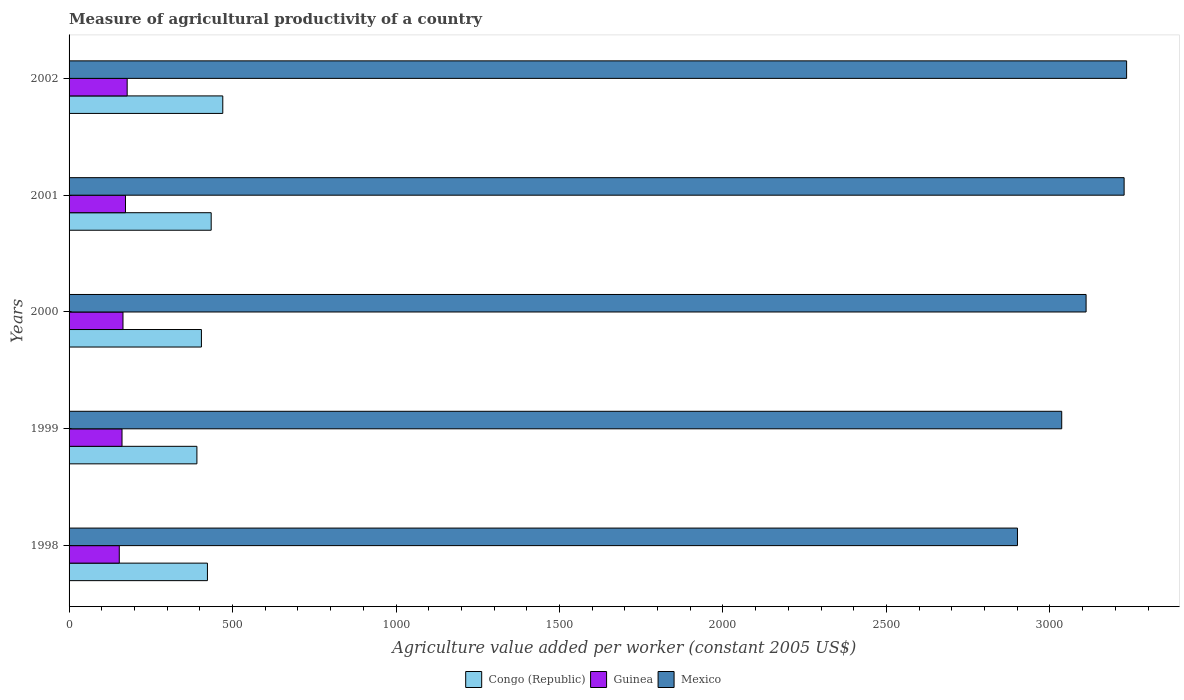How many groups of bars are there?
Make the answer very short. 5. Are the number of bars per tick equal to the number of legend labels?
Keep it short and to the point. Yes. How many bars are there on the 5th tick from the bottom?
Keep it short and to the point. 3. What is the label of the 1st group of bars from the top?
Your answer should be compact. 2002. What is the measure of agricultural productivity in Mexico in 2002?
Your answer should be very brief. 3234.55. Across all years, what is the maximum measure of agricultural productivity in Guinea?
Your answer should be compact. 177.71. Across all years, what is the minimum measure of agricultural productivity in Guinea?
Provide a short and direct response. 153.55. In which year was the measure of agricultural productivity in Congo (Republic) maximum?
Your answer should be compact. 2002. What is the total measure of agricultural productivity in Mexico in the graph?
Offer a very short reply. 1.55e+04. What is the difference between the measure of agricultural productivity in Congo (Republic) in 1998 and that in 2001?
Your answer should be very brief. -11.48. What is the difference between the measure of agricultural productivity in Guinea in 1998 and the measure of agricultural productivity in Mexico in 2002?
Your response must be concise. -3081. What is the average measure of agricultural productivity in Mexico per year?
Your answer should be compact. 3101.79. In the year 2001, what is the difference between the measure of agricultural productivity in Guinea and measure of agricultural productivity in Mexico?
Your answer should be compact. -3054.34. In how many years, is the measure of agricultural productivity in Mexico greater than 1200 US$?
Make the answer very short. 5. What is the ratio of the measure of agricultural productivity in Mexico in 2000 to that in 2001?
Ensure brevity in your answer.  0.96. Is the measure of agricultural productivity in Congo (Republic) in 1998 less than that in 2000?
Your response must be concise. No. What is the difference between the highest and the second highest measure of agricultural productivity in Guinea?
Make the answer very short. 5.1. What is the difference between the highest and the lowest measure of agricultural productivity in Mexico?
Ensure brevity in your answer.  333.81. Is the sum of the measure of agricultural productivity in Guinea in 1999 and 2001 greater than the maximum measure of agricultural productivity in Mexico across all years?
Keep it short and to the point. No. What does the 3rd bar from the top in 2001 represents?
Ensure brevity in your answer.  Congo (Republic). What does the 1st bar from the bottom in 2001 represents?
Keep it short and to the point. Congo (Republic). Is it the case that in every year, the sum of the measure of agricultural productivity in Congo (Republic) and measure of agricultural productivity in Guinea is greater than the measure of agricultural productivity in Mexico?
Give a very brief answer. No. How many bars are there?
Ensure brevity in your answer.  15. How many years are there in the graph?
Offer a terse response. 5. Does the graph contain grids?
Give a very brief answer. No. Where does the legend appear in the graph?
Ensure brevity in your answer.  Bottom center. How many legend labels are there?
Your answer should be very brief. 3. How are the legend labels stacked?
Give a very brief answer. Horizontal. What is the title of the graph?
Ensure brevity in your answer.  Measure of agricultural productivity of a country. What is the label or title of the X-axis?
Your response must be concise. Agriculture value added per worker (constant 2005 US$). What is the label or title of the Y-axis?
Your answer should be compact. Years. What is the Agriculture value added per worker (constant 2005 US$) of Congo (Republic) in 1998?
Ensure brevity in your answer.  423.21. What is the Agriculture value added per worker (constant 2005 US$) in Guinea in 1998?
Give a very brief answer. 153.55. What is the Agriculture value added per worker (constant 2005 US$) in Mexico in 1998?
Ensure brevity in your answer.  2900.74. What is the Agriculture value added per worker (constant 2005 US$) of Congo (Republic) in 1999?
Provide a short and direct response. 391.01. What is the Agriculture value added per worker (constant 2005 US$) in Guinea in 1999?
Provide a short and direct response. 161.95. What is the Agriculture value added per worker (constant 2005 US$) of Mexico in 1999?
Your answer should be very brief. 3036.08. What is the Agriculture value added per worker (constant 2005 US$) of Congo (Republic) in 2000?
Give a very brief answer. 404.82. What is the Agriculture value added per worker (constant 2005 US$) of Guinea in 2000?
Offer a very short reply. 164.91. What is the Agriculture value added per worker (constant 2005 US$) in Mexico in 2000?
Keep it short and to the point. 3110.61. What is the Agriculture value added per worker (constant 2005 US$) in Congo (Republic) in 2001?
Keep it short and to the point. 434.69. What is the Agriculture value added per worker (constant 2005 US$) of Guinea in 2001?
Provide a short and direct response. 172.61. What is the Agriculture value added per worker (constant 2005 US$) of Mexico in 2001?
Keep it short and to the point. 3226.94. What is the Agriculture value added per worker (constant 2005 US$) in Congo (Republic) in 2002?
Keep it short and to the point. 470.11. What is the Agriculture value added per worker (constant 2005 US$) of Guinea in 2002?
Give a very brief answer. 177.71. What is the Agriculture value added per worker (constant 2005 US$) in Mexico in 2002?
Offer a very short reply. 3234.55. Across all years, what is the maximum Agriculture value added per worker (constant 2005 US$) in Congo (Republic)?
Give a very brief answer. 470.11. Across all years, what is the maximum Agriculture value added per worker (constant 2005 US$) in Guinea?
Your answer should be compact. 177.71. Across all years, what is the maximum Agriculture value added per worker (constant 2005 US$) of Mexico?
Provide a short and direct response. 3234.55. Across all years, what is the minimum Agriculture value added per worker (constant 2005 US$) in Congo (Republic)?
Keep it short and to the point. 391.01. Across all years, what is the minimum Agriculture value added per worker (constant 2005 US$) of Guinea?
Your response must be concise. 153.55. Across all years, what is the minimum Agriculture value added per worker (constant 2005 US$) of Mexico?
Ensure brevity in your answer.  2900.74. What is the total Agriculture value added per worker (constant 2005 US$) of Congo (Republic) in the graph?
Keep it short and to the point. 2123.84. What is the total Agriculture value added per worker (constant 2005 US$) of Guinea in the graph?
Make the answer very short. 830.73. What is the total Agriculture value added per worker (constant 2005 US$) of Mexico in the graph?
Offer a very short reply. 1.55e+04. What is the difference between the Agriculture value added per worker (constant 2005 US$) in Congo (Republic) in 1998 and that in 1999?
Give a very brief answer. 32.2. What is the difference between the Agriculture value added per worker (constant 2005 US$) in Guinea in 1998 and that in 1999?
Make the answer very short. -8.4. What is the difference between the Agriculture value added per worker (constant 2005 US$) of Mexico in 1998 and that in 1999?
Offer a very short reply. -135.34. What is the difference between the Agriculture value added per worker (constant 2005 US$) in Congo (Republic) in 1998 and that in 2000?
Keep it short and to the point. 18.39. What is the difference between the Agriculture value added per worker (constant 2005 US$) of Guinea in 1998 and that in 2000?
Ensure brevity in your answer.  -11.36. What is the difference between the Agriculture value added per worker (constant 2005 US$) of Mexico in 1998 and that in 2000?
Keep it short and to the point. -209.87. What is the difference between the Agriculture value added per worker (constant 2005 US$) of Congo (Republic) in 1998 and that in 2001?
Give a very brief answer. -11.48. What is the difference between the Agriculture value added per worker (constant 2005 US$) of Guinea in 1998 and that in 2001?
Your response must be concise. -19.06. What is the difference between the Agriculture value added per worker (constant 2005 US$) of Mexico in 1998 and that in 2001?
Offer a terse response. -326.2. What is the difference between the Agriculture value added per worker (constant 2005 US$) in Congo (Republic) in 1998 and that in 2002?
Offer a terse response. -46.9. What is the difference between the Agriculture value added per worker (constant 2005 US$) of Guinea in 1998 and that in 2002?
Keep it short and to the point. -24.16. What is the difference between the Agriculture value added per worker (constant 2005 US$) in Mexico in 1998 and that in 2002?
Offer a terse response. -333.81. What is the difference between the Agriculture value added per worker (constant 2005 US$) of Congo (Republic) in 1999 and that in 2000?
Give a very brief answer. -13.8. What is the difference between the Agriculture value added per worker (constant 2005 US$) of Guinea in 1999 and that in 2000?
Provide a succinct answer. -2.96. What is the difference between the Agriculture value added per worker (constant 2005 US$) of Mexico in 1999 and that in 2000?
Make the answer very short. -74.53. What is the difference between the Agriculture value added per worker (constant 2005 US$) in Congo (Republic) in 1999 and that in 2001?
Keep it short and to the point. -43.68. What is the difference between the Agriculture value added per worker (constant 2005 US$) of Guinea in 1999 and that in 2001?
Provide a short and direct response. -10.66. What is the difference between the Agriculture value added per worker (constant 2005 US$) in Mexico in 1999 and that in 2001?
Keep it short and to the point. -190.87. What is the difference between the Agriculture value added per worker (constant 2005 US$) of Congo (Republic) in 1999 and that in 2002?
Provide a succinct answer. -79.1. What is the difference between the Agriculture value added per worker (constant 2005 US$) in Guinea in 1999 and that in 2002?
Your answer should be very brief. -15.76. What is the difference between the Agriculture value added per worker (constant 2005 US$) of Mexico in 1999 and that in 2002?
Make the answer very short. -198.47. What is the difference between the Agriculture value added per worker (constant 2005 US$) of Congo (Republic) in 2000 and that in 2001?
Provide a succinct answer. -29.87. What is the difference between the Agriculture value added per worker (constant 2005 US$) of Guinea in 2000 and that in 2001?
Make the answer very short. -7.69. What is the difference between the Agriculture value added per worker (constant 2005 US$) of Mexico in 2000 and that in 2001?
Keep it short and to the point. -116.33. What is the difference between the Agriculture value added per worker (constant 2005 US$) of Congo (Republic) in 2000 and that in 2002?
Make the answer very short. -65.29. What is the difference between the Agriculture value added per worker (constant 2005 US$) of Guinea in 2000 and that in 2002?
Make the answer very short. -12.79. What is the difference between the Agriculture value added per worker (constant 2005 US$) in Mexico in 2000 and that in 2002?
Your answer should be compact. -123.94. What is the difference between the Agriculture value added per worker (constant 2005 US$) of Congo (Republic) in 2001 and that in 2002?
Offer a terse response. -35.42. What is the difference between the Agriculture value added per worker (constant 2005 US$) in Guinea in 2001 and that in 2002?
Ensure brevity in your answer.  -5.1. What is the difference between the Agriculture value added per worker (constant 2005 US$) of Mexico in 2001 and that in 2002?
Offer a terse response. -7.61. What is the difference between the Agriculture value added per worker (constant 2005 US$) in Congo (Republic) in 1998 and the Agriculture value added per worker (constant 2005 US$) in Guinea in 1999?
Provide a succinct answer. 261.26. What is the difference between the Agriculture value added per worker (constant 2005 US$) of Congo (Republic) in 1998 and the Agriculture value added per worker (constant 2005 US$) of Mexico in 1999?
Give a very brief answer. -2612.87. What is the difference between the Agriculture value added per worker (constant 2005 US$) in Guinea in 1998 and the Agriculture value added per worker (constant 2005 US$) in Mexico in 1999?
Your answer should be compact. -2882.53. What is the difference between the Agriculture value added per worker (constant 2005 US$) of Congo (Republic) in 1998 and the Agriculture value added per worker (constant 2005 US$) of Guinea in 2000?
Give a very brief answer. 258.3. What is the difference between the Agriculture value added per worker (constant 2005 US$) in Congo (Republic) in 1998 and the Agriculture value added per worker (constant 2005 US$) in Mexico in 2000?
Provide a succinct answer. -2687.4. What is the difference between the Agriculture value added per worker (constant 2005 US$) of Guinea in 1998 and the Agriculture value added per worker (constant 2005 US$) of Mexico in 2000?
Provide a succinct answer. -2957.06. What is the difference between the Agriculture value added per worker (constant 2005 US$) of Congo (Republic) in 1998 and the Agriculture value added per worker (constant 2005 US$) of Guinea in 2001?
Provide a short and direct response. 250.6. What is the difference between the Agriculture value added per worker (constant 2005 US$) in Congo (Republic) in 1998 and the Agriculture value added per worker (constant 2005 US$) in Mexico in 2001?
Offer a very short reply. -2803.73. What is the difference between the Agriculture value added per worker (constant 2005 US$) in Guinea in 1998 and the Agriculture value added per worker (constant 2005 US$) in Mexico in 2001?
Give a very brief answer. -3073.39. What is the difference between the Agriculture value added per worker (constant 2005 US$) of Congo (Republic) in 1998 and the Agriculture value added per worker (constant 2005 US$) of Guinea in 2002?
Your response must be concise. 245.5. What is the difference between the Agriculture value added per worker (constant 2005 US$) in Congo (Republic) in 1998 and the Agriculture value added per worker (constant 2005 US$) in Mexico in 2002?
Your answer should be very brief. -2811.34. What is the difference between the Agriculture value added per worker (constant 2005 US$) of Guinea in 1998 and the Agriculture value added per worker (constant 2005 US$) of Mexico in 2002?
Your answer should be compact. -3081. What is the difference between the Agriculture value added per worker (constant 2005 US$) of Congo (Republic) in 1999 and the Agriculture value added per worker (constant 2005 US$) of Guinea in 2000?
Keep it short and to the point. 226.1. What is the difference between the Agriculture value added per worker (constant 2005 US$) of Congo (Republic) in 1999 and the Agriculture value added per worker (constant 2005 US$) of Mexico in 2000?
Provide a succinct answer. -2719.6. What is the difference between the Agriculture value added per worker (constant 2005 US$) in Guinea in 1999 and the Agriculture value added per worker (constant 2005 US$) in Mexico in 2000?
Provide a succinct answer. -2948.66. What is the difference between the Agriculture value added per worker (constant 2005 US$) of Congo (Republic) in 1999 and the Agriculture value added per worker (constant 2005 US$) of Guinea in 2001?
Your answer should be very brief. 218.41. What is the difference between the Agriculture value added per worker (constant 2005 US$) of Congo (Republic) in 1999 and the Agriculture value added per worker (constant 2005 US$) of Mexico in 2001?
Ensure brevity in your answer.  -2835.93. What is the difference between the Agriculture value added per worker (constant 2005 US$) in Guinea in 1999 and the Agriculture value added per worker (constant 2005 US$) in Mexico in 2001?
Give a very brief answer. -3064.99. What is the difference between the Agriculture value added per worker (constant 2005 US$) in Congo (Republic) in 1999 and the Agriculture value added per worker (constant 2005 US$) in Guinea in 2002?
Make the answer very short. 213.31. What is the difference between the Agriculture value added per worker (constant 2005 US$) of Congo (Republic) in 1999 and the Agriculture value added per worker (constant 2005 US$) of Mexico in 2002?
Offer a terse response. -2843.54. What is the difference between the Agriculture value added per worker (constant 2005 US$) in Guinea in 1999 and the Agriculture value added per worker (constant 2005 US$) in Mexico in 2002?
Keep it short and to the point. -3072.6. What is the difference between the Agriculture value added per worker (constant 2005 US$) in Congo (Republic) in 2000 and the Agriculture value added per worker (constant 2005 US$) in Guinea in 2001?
Offer a very short reply. 232.21. What is the difference between the Agriculture value added per worker (constant 2005 US$) of Congo (Republic) in 2000 and the Agriculture value added per worker (constant 2005 US$) of Mexico in 2001?
Your answer should be very brief. -2822.13. What is the difference between the Agriculture value added per worker (constant 2005 US$) of Guinea in 2000 and the Agriculture value added per worker (constant 2005 US$) of Mexico in 2001?
Provide a short and direct response. -3062.03. What is the difference between the Agriculture value added per worker (constant 2005 US$) of Congo (Republic) in 2000 and the Agriculture value added per worker (constant 2005 US$) of Guinea in 2002?
Give a very brief answer. 227.11. What is the difference between the Agriculture value added per worker (constant 2005 US$) in Congo (Republic) in 2000 and the Agriculture value added per worker (constant 2005 US$) in Mexico in 2002?
Offer a terse response. -2829.74. What is the difference between the Agriculture value added per worker (constant 2005 US$) in Guinea in 2000 and the Agriculture value added per worker (constant 2005 US$) in Mexico in 2002?
Provide a short and direct response. -3069.64. What is the difference between the Agriculture value added per worker (constant 2005 US$) in Congo (Republic) in 2001 and the Agriculture value added per worker (constant 2005 US$) in Guinea in 2002?
Your answer should be very brief. 256.98. What is the difference between the Agriculture value added per worker (constant 2005 US$) of Congo (Republic) in 2001 and the Agriculture value added per worker (constant 2005 US$) of Mexico in 2002?
Ensure brevity in your answer.  -2799.86. What is the difference between the Agriculture value added per worker (constant 2005 US$) in Guinea in 2001 and the Agriculture value added per worker (constant 2005 US$) in Mexico in 2002?
Provide a succinct answer. -3061.95. What is the average Agriculture value added per worker (constant 2005 US$) in Congo (Republic) per year?
Your response must be concise. 424.77. What is the average Agriculture value added per worker (constant 2005 US$) in Guinea per year?
Offer a terse response. 166.15. What is the average Agriculture value added per worker (constant 2005 US$) in Mexico per year?
Keep it short and to the point. 3101.79. In the year 1998, what is the difference between the Agriculture value added per worker (constant 2005 US$) of Congo (Republic) and Agriculture value added per worker (constant 2005 US$) of Guinea?
Provide a short and direct response. 269.66. In the year 1998, what is the difference between the Agriculture value added per worker (constant 2005 US$) in Congo (Republic) and Agriculture value added per worker (constant 2005 US$) in Mexico?
Ensure brevity in your answer.  -2477.53. In the year 1998, what is the difference between the Agriculture value added per worker (constant 2005 US$) of Guinea and Agriculture value added per worker (constant 2005 US$) of Mexico?
Ensure brevity in your answer.  -2747.19. In the year 1999, what is the difference between the Agriculture value added per worker (constant 2005 US$) in Congo (Republic) and Agriculture value added per worker (constant 2005 US$) in Guinea?
Keep it short and to the point. 229.06. In the year 1999, what is the difference between the Agriculture value added per worker (constant 2005 US$) in Congo (Republic) and Agriculture value added per worker (constant 2005 US$) in Mexico?
Make the answer very short. -2645.07. In the year 1999, what is the difference between the Agriculture value added per worker (constant 2005 US$) of Guinea and Agriculture value added per worker (constant 2005 US$) of Mexico?
Offer a terse response. -2874.13. In the year 2000, what is the difference between the Agriculture value added per worker (constant 2005 US$) of Congo (Republic) and Agriculture value added per worker (constant 2005 US$) of Guinea?
Offer a very short reply. 239.9. In the year 2000, what is the difference between the Agriculture value added per worker (constant 2005 US$) of Congo (Republic) and Agriculture value added per worker (constant 2005 US$) of Mexico?
Offer a terse response. -2705.79. In the year 2000, what is the difference between the Agriculture value added per worker (constant 2005 US$) of Guinea and Agriculture value added per worker (constant 2005 US$) of Mexico?
Keep it short and to the point. -2945.7. In the year 2001, what is the difference between the Agriculture value added per worker (constant 2005 US$) in Congo (Republic) and Agriculture value added per worker (constant 2005 US$) in Guinea?
Ensure brevity in your answer.  262.08. In the year 2001, what is the difference between the Agriculture value added per worker (constant 2005 US$) of Congo (Republic) and Agriculture value added per worker (constant 2005 US$) of Mexico?
Provide a succinct answer. -2792.25. In the year 2001, what is the difference between the Agriculture value added per worker (constant 2005 US$) in Guinea and Agriculture value added per worker (constant 2005 US$) in Mexico?
Give a very brief answer. -3054.34. In the year 2002, what is the difference between the Agriculture value added per worker (constant 2005 US$) in Congo (Republic) and Agriculture value added per worker (constant 2005 US$) in Guinea?
Provide a succinct answer. 292.4. In the year 2002, what is the difference between the Agriculture value added per worker (constant 2005 US$) of Congo (Republic) and Agriculture value added per worker (constant 2005 US$) of Mexico?
Ensure brevity in your answer.  -2764.44. In the year 2002, what is the difference between the Agriculture value added per worker (constant 2005 US$) of Guinea and Agriculture value added per worker (constant 2005 US$) of Mexico?
Make the answer very short. -3056.85. What is the ratio of the Agriculture value added per worker (constant 2005 US$) of Congo (Republic) in 1998 to that in 1999?
Provide a short and direct response. 1.08. What is the ratio of the Agriculture value added per worker (constant 2005 US$) in Guinea in 1998 to that in 1999?
Offer a terse response. 0.95. What is the ratio of the Agriculture value added per worker (constant 2005 US$) of Mexico in 1998 to that in 1999?
Offer a very short reply. 0.96. What is the ratio of the Agriculture value added per worker (constant 2005 US$) in Congo (Republic) in 1998 to that in 2000?
Make the answer very short. 1.05. What is the ratio of the Agriculture value added per worker (constant 2005 US$) of Guinea in 1998 to that in 2000?
Make the answer very short. 0.93. What is the ratio of the Agriculture value added per worker (constant 2005 US$) of Mexico in 1998 to that in 2000?
Your response must be concise. 0.93. What is the ratio of the Agriculture value added per worker (constant 2005 US$) of Congo (Republic) in 1998 to that in 2001?
Offer a very short reply. 0.97. What is the ratio of the Agriculture value added per worker (constant 2005 US$) of Guinea in 1998 to that in 2001?
Your response must be concise. 0.89. What is the ratio of the Agriculture value added per worker (constant 2005 US$) of Mexico in 1998 to that in 2001?
Your response must be concise. 0.9. What is the ratio of the Agriculture value added per worker (constant 2005 US$) in Congo (Republic) in 1998 to that in 2002?
Your response must be concise. 0.9. What is the ratio of the Agriculture value added per worker (constant 2005 US$) of Guinea in 1998 to that in 2002?
Provide a succinct answer. 0.86. What is the ratio of the Agriculture value added per worker (constant 2005 US$) in Mexico in 1998 to that in 2002?
Give a very brief answer. 0.9. What is the ratio of the Agriculture value added per worker (constant 2005 US$) of Congo (Republic) in 1999 to that in 2000?
Your answer should be compact. 0.97. What is the ratio of the Agriculture value added per worker (constant 2005 US$) in Congo (Republic) in 1999 to that in 2001?
Keep it short and to the point. 0.9. What is the ratio of the Agriculture value added per worker (constant 2005 US$) in Guinea in 1999 to that in 2001?
Your response must be concise. 0.94. What is the ratio of the Agriculture value added per worker (constant 2005 US$) in Mexico in 1999 to that in 2001?
Give a very brief answer. 0.94. What is the ratio of the Agriculture value added per worker (constant 2005 US$) in Congo (Republic) in 1999 to that in 2002?
Keep it short and to the point. 0.83. What is the ratio of the Agriculture value added per worker (constant 2005 US$) of Guinea in 1999 to that in 2002?
Provide a succinct answer. 0.91. What is the ratio of the Agriculture value added per worker (constant 2005 US$) in Mexico in 1999 to that in 2002?
Provide a short and direct response. 0.94. What is the ratio of the Agriculture value added per worker (constant 2005 US$) of Congo (Republic) in 2000 to that in 2001?
Provide a short and direct response. 0.93. What is the ratio of the Agriculture value added per worker (constant 2005 US$) in Guinea in 2000 to that in 2001?
Keep it short and to the point. 0.96. What is the ratio of the Agriculture value added per worker (constant 2005 US$) in Mexico in 2000 to that in 2001?
Your response must be concise. 0.96. What is the ratio of the Agriculture value added per worker (constant 2005 US$) in Congo (Republic) in 2000 to that in 2002?
Your response must be concise. 0.86. What is the ratio of the Agriculture value added per worker (constant 2005 US$) in Guinea in 2000 to that in 2002?
Your answer should be very brief. 0.93. What is the ratio of the Agriculture value added per worker (constant 2005 US$) of Mexico in 2000 to that in 2002?
Your response must be concise. 0.96. What is the ratio of the Agriculture value added per worker (constant 2005 US$) in Congo (Republic) in 2001 to that in 2002?
Your answer should be very brief. 0.92. What is the ratio of the Agriculture value added per worker (constant 2005 US$) of Guinea in 2001 to that in 2002?
Your response must be concise. 0.97. What is the difference between the highest and the second highest Agriculture value added per worker (constant 2005 US$) in Congo (Republic)?
Make the answer very short. 35.42. What is the difference between the highest and the second highest Agriculture value added per worker (constant 2005 US$) in Guinea?
Your answer should be very brief. 5.1. What is the difference between the highest and the second highest Agriculture value added per worker (constant 2005 US$) of Mexico?
Provide a short and direct response. 7.61. What is the difference between the highest and the lowest Agriculture value added per worker (constant 2005 US$) of Congo (Republic)?
Keep it short and to the point. 79.1. What is the difference between the highest and the lowest Agriculture value added per worker (constant 2005 US$) in Guinea?
Your answer should be compact. 24.16. What is the difference between the highest and the lowest Agriculture value added per worker (constant 2005 US$) of Mexico?
Provide a succinct answer. 333.81. 